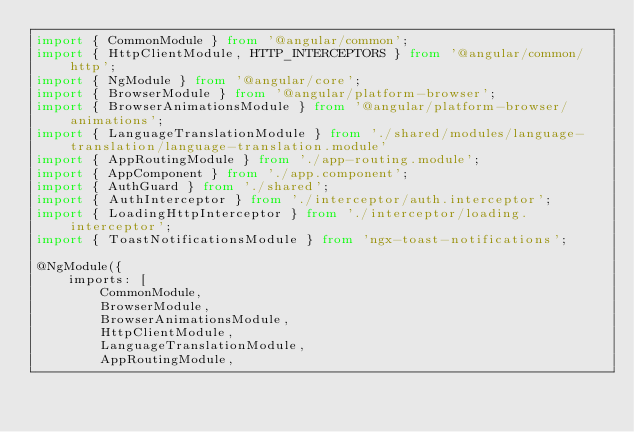Convert code to text. <code><loc_0><loc_0><loc_500><loc_500><_TypeScript_>import { CommonModule } from '@angular/common';
import { HttpClientModule, HTTP_INTERCEPTORS } from '@angular/common/http';
import { NgModule } from '@angular/core';
import { BrowserModule } from '@angular/platform-browser';
import { BrowserAnimationsModule } from '@angular/platform-browser/animations';
import { LanguageTranslationModule } from './shared/modules/language-translation/language-translation.module'
import { AppRoutingModule } from './app-routing.module';
import { AppComponent } from './app.component';
import { AuthGuard } from './shared';
import { AuthInterceptor } from './interceptor/auth.interceptor';
import { LoadingHttpInterceptor } from './interceptor/loading.interceptor';
import { ToastNotificationsModule } from 'ngx-toast-notifications';

@NgModule({
    imports: [
        CommonModule,
        BrowserModule,
        BrowserAnimationsModule,
        HttpClientModule,
        LanguageTranslationModule,
        AppRoutingModule,</code> 